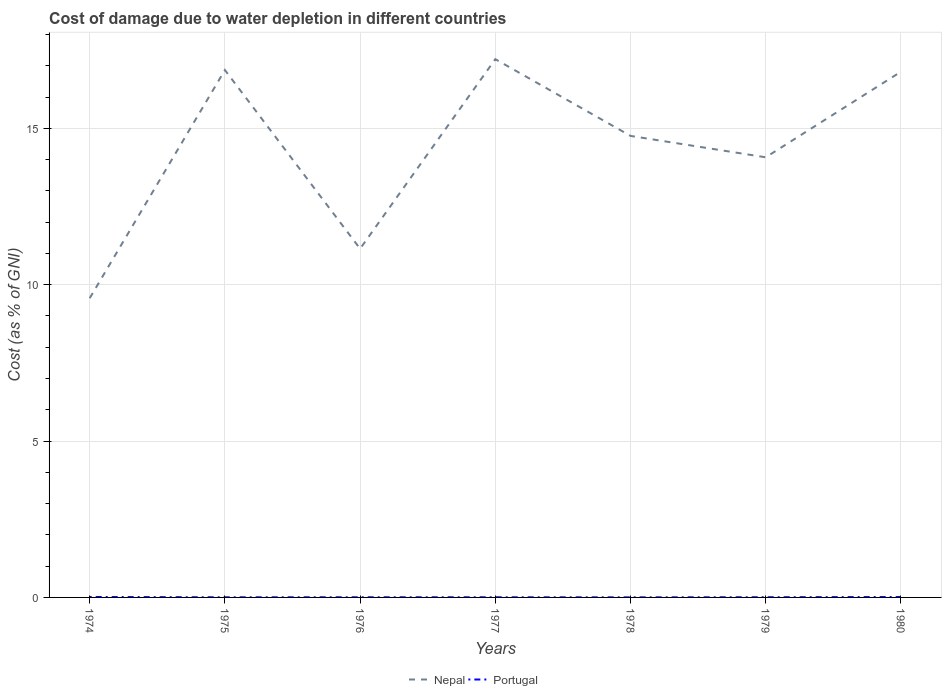How many different coloured lines are there?
Give a very brief answer. 2. Across all years, what is the maximum cost of damage caused due to water depletion in Nepal?
Make the answer very short. 9.57. In which year was the cost of damage caused due to water depletion in Nepal maximum?
Make the answer very short. 1974. What is the total cost of damage caused due to water depletion in Portugal in the graph?
Ensure brevity in your answer.  0.01. What is the difference between the highest and the second highest cost of damage caused due to water depletion in Nepal?
Your answer should be compact. 7.64. What is the title of the graph?
Provide a short and direct response. Cost of damage due to water depletion in different countries. Does "Sweden" appear as one of the legend labels in the graph?
Provide a short and direct response. No. What is the label or title of the Y-axis?
Give a very brief answer. Cost (as % of GNI). What is the Cost (as % of GNI) in Nepal in 1974?
Provide a short and direct response. 9.57. What is the Cost (as % of GNI) in Portugal in 1974?
Make the answer very short. 0.01. What is the Cost (as % of GNI) of Nepal in 1975?
Your response must be concise. 16.86. What is the Cost (as % of GNI) of Portugal in 1975?
Your answer should be very brief. 0. What is the Cost (as % of GNI) in Nepal in 1976?
Offer a terse response. 11.15. What is the Cost (as % of GNI) in Portugal in 1976?
Make the answer very short. 0.01. What is the Cost (as % of GNI) in Nepal in 1977?
Offer a terse response. 17.21. What is the Cost (as % of GNI) in Portugal in 1977?
Make the answer very short. 0. What is the Cost (as % of GNI) of Nepal in 1978?
Keep it short and to the point. 14.76. What is the Cost (as % of GNI) in Portugal in 1978?
Your answer should be compact. 0. What is the Cost (as % of GNI) of Nepal in 1979?
Provide a short and direct response. 14.07. What is the Cost (as % of GNI) of Portugal in 1979?
Ensure brevity in your answer.  0.01. What is the Cost (as % of GNI) in Nepal in 1980?
Offer a terse response. 16.81. What is the Cost (as % of GNI) in Portugal in 1980?
Your answer should be compact. 0.01. Across all years, what is the maximum Cost (as % of GNI) of Nepal?
Make the answer very short. 17.21. Across all years, what is the maximum Cost (as % of GNI) in Portugal?
Your answer should be very brief. 0.01. Across all years, what is the minimum Cost (as % of GNI) in Nepal?
Offer a very short reply. 9.57. Across all years, what is the minimum Cost (as % of GNI) of Portugal?
Provide a short and direct response. 0. What is the total Cost (as % of GNI) in Nepal in the graph?
Provide a short and direct response. 100.44. What is the total Cost (as % of GNI) of Portugal in the graph?
Give a very brief answer. 0.05. What is the difference between the Cost (as % of GNI) in Nepal in 1974 and that in 1975?
Offer a very short reply. -7.3. What is the difference between the Cost (as % of GNI) in Portugal in 1974 and that in 1975?
Ensure brevity in your answer.  0.01. What is the difference between the Cost (as % of GNI) in Nepal in 1974 and that in 1976?
Provide a succinct answer. -1.58. What is the difference between the Cost (as % of GNI) of Portugal in 1974 and that in 1976?
Keep it short and to the point. 0.01. What is the difference between the Cost (as % of GNI) in Nepal in 1974 and that in 1977?
Ensure brevity in your answer.  -7.64. What is the difference between the Cost (as % of GNI) of Portugal in 1974 and that in 1977?
Your answer should be very brief. 0.01. What is the difference between the Cost (as % of GNI) of Nepal in 1974 and that in 1978?
Give a very brief answer. -5.19. What is the difference between the Cost (as % of GNI) in Portugal in 1974 and that in 1978?
Ensure brevity in your answer.  0.01. What is the difference between the Cost (as % of GNI) of Nepal in 1974 and that in 1979?
Your answer should be very brief. -4.51. What is the difference between the Cost (as % of GNI) of Portugal in 1974 and that in 1979?
Offer a terse response. 0.01. What is the difference between the Cost (as % of GNI) of Nepal in 1974 and that in 1980?
Offer a terse response. -7.24. What is the difference between the Cost (as % of GNI) in Portugal in 1974 and that in 1980?
Make the answer very short. 0. What is the difference between the Cost (as % of GNI) of Nepal in 1975 and that in 1976?
Offer a terse response. 5.71. What is the difference between the Cost (as % of GNI) in Portugal in 1975 and that in 1976?
Your answer should be compact. -0. What is the difference between the Cost (as % of GNI) of Nepal in 1975 and that in 1977?
Offer a very short reply. -0.35. What is the difference between the Cost (as % of GNI) in Portugal in 1975 and that in 1977?
Your answer should be very brief. -0. What is the difference between the Cost (as % of GNI) in Nepal in 1975 and that in 1978?
Keep it short and to the point. 2.11. What is the difference between the Cost (as % of GNI) in Portugal in 1975 and that in 1978?
Ensure brevity in your answer.  0. What is the difference between the Cost (as % of GNI) in Nepal in 1975 and that in 1979?
Give a very brief answer. 2.79. What is the difference between the Cost (as % of GNI) of Portugal in 1975 and that in 1979?
Your answer should be very brief. -0. What is the difference between the Cost (as % of GNI) of Nepal in 1975 and that in 1980?
Your answer should be compact. 0.05. What is the difference between the Cost (as % of GNI) of Portugal in 1975 and that in 1980?
Provide a short and direct response. -0.01. What is the difference between the Cost (as % of GNI) of Nepal in 1976 and that in 1977?
Your answer should be compact. -6.06. What is the difference between the Cost (as % of GNI) of Portugal in 1976 and that in 1977?
Keep it short and to the point. 0. What is the difference between the Cost (as % of GNI) in Nepal in 1976 and that in 1978?
Offer a terse response. -3.61. What is the difference between the Cost (as % of GNI) in Portugal in 1976 and that in 1978?
Your response must be concise. 0. What is the difference between the Cost (as % of GNI) of Nepal in 1976 and that in 1979?
Your answer should be very brief. -2.92. What is the difference between the Cost (as % of GNI) of Portugal in 1976 and that in 1979?
Your response must be concise. -0. What is the difference between the Cost (as % of GNI) in Nepal in 1976 and that in 1980?
Your answer should be compact. -5.66. What is the difference between the Cost (as % of GNI) of Portugal in 1976 and that in 1980?
Your response must be concise. -0.01. What is the difference between the Cost (as % of GNI) in Nepal in 1977 and that in 1978?
Your answer should be compact. 2.45. What is the difference between the Cost (as % of GNI) in Portugal in 1977 and that in 1978?
Your answer should be very brief. 0. What is the difference between the Cost (as % of GNI) in Nepal in 1977 and that in 1979?
Keep it short and to the point. 3.14. What is the difference between the Cost (as % of GNI) in Portugal in 1977 and that in 1979?
Give a very brief answer. -0. What is the difference between the Cost (as % of GNI) in Nepal in 1977 and that in 1980?
Provide a succinct answer. 0.4. What is the difference between the Cost (as % of GNI) of Portugal in 1977 and that in 1980?
Your response must be concise. -0.01. What is the difference between the Cost (as % of GNI) in Nepal in 1978 and that in 1979?
Your answer should be very brief. 0.68. What is the difference between the Cost (as % of GNI) of Portugal in 1978 and that in 1979?
Provide a short and direct response. -0. What is the difference between the Cost (as % of GNI) in Nepal in 1978 and that in 1980?
Provide a short and direct response. -2.05. What is the difference between the Cost (as % of GNI) of Portugal in 1978 and that in 1980?
Provide a succinct answer. -0.01. What is the difference between the Cost (as % of GNI) of Nepal in 1979 and that in 1980?
Provide a short and direct response. -2.74. What is the difference between the Cost (as % of GNI) of Portugal in 1979 and that in 1980?
Your answer should be compact. -0.01. What is the difference between the Cost (as % of GNI) of Nepal in 1974 and the Cost (as % of GNI) of Portugal in 1975?
Provide a short and direct response. 9.56. What is the difference between the Cost (as % of GNI) in Nepal in 1974 and the Cost (as % of GNI) in Portugal in 1976?
Your answer should be very brief. 9.56. What is the difference between the Cost (as % of GNI) of Nepal in 1974 and the Cost (as % of GNI) of Portugal in 1977?
Provide a succinct answer. 9.56. What is the difference between the Cost (as % of GNI) of Nepal in 1974 and the Cost (as % of GNI) of Portugal in 1978?
Ensure brevity in your answer.  9.57. What is the difference between the Cost (as % of GNI) in Nepal in 1974 and the Cost (as % of GNI) in Portugal in 1979?
Give a very brief answer. 9.56. What is the difference between the Cost (as % of GNI) in Nepal in 1974 and the Cost (as % of GNI) in Portugal in 1980?
Make the answer very short. 9.56. What is the difference between the Cost (as % of GNI) of Nepal in 1975 and the Cost (as % of GNI) of Portugal in 1976?
Your answer should be compact. 16.86. What is the difference between the Cost (as % of GNI) of Nepal in 1975 and the Cost (as % of GNI) of Portugal in 1977?
Ensure brevity in your answer.  16.86. What is the difference between the Cost (as % of GNI) of Nepal in 1975 and the Cost (as % of GNI) of Portugal in 1978?
Your response must be concise. 16.86. What is the difference between the Cost (as % of GNI) in Nepal in 1975 and the Cost (as % of GNI) in Portugal in 1979?
Give a very brief answer. 16.86. What is the difference between the Cost (as % of GNI) of Nepal in 1975 and the Cost (as % of GNI) of Portugal in 1980?
Your answer should be very brief. 16.85. What is the difference between the Cost (as % of GNI) of Nepal in 1976 and the Cost (as % of GNI) of Portugal in 1977?
Provide a short and direct response. 11.15. What is the difference between the Cost (as % of GNI) in Nepal in 1976 and the Cost (as % of GNI) in Portugal in 1978?
Give a very brief answer. 11.15. What is the difference between the Cost (as % of GNI) in Nepal in 1976 and the Cost (as % of GNI) in Portugal in 1979?
Offer a very short reply. 11.14. What is the difference between the Cost (as % of GNI) of Nepal in 1976 and the Cost (as % of GNI) of Portugal in 1980?
Your answer should be compact. 11.14. What is the difference between the Cost (as % of GNI) in Nepal in 1977 and the Cost (as % of GNI) in Portugal in 1978?
Offer a very short reply. 17.21. What is the difference between the Cost (as % of GNI) of Nepal in 1977 and the Cost (as % of GNI) of Portugal in 1979?
Keep it short and to the point. 17.21. What is the difference between the Cost (as % of GNI) of Nepal in 1977 and the Cost (as % of GNI) of Portugal in 1980?
Keep it short and to the point. 17.2. What is the difference between the Cost (as % of GNI) in Nepal in 1978 and the Cost (as % of GNI) in Portugal in 1979?
Offer a terse response. 14.75. What is the difference between the Cost (as % of GNI) in Nepal in 1978 and the Cost (as % of GNI) in Portugal in 1980?
Offer a very short reply. 14.75. What is the difference between the Cost (as % of GNI) of Nepal in 1979 and the Cost (as % of GNI) of Portugal in 1980?
Your answer should be compact. 14.06. What is the average Cost (as % of GNI) in Nepal per year?
Offer a terse response. 14.35. What is the average Cost (as % of GNI) of Portugal per year?
Ensure brevity in your answer.  0.01. In the year 1974, what is the difference between the Cost (as % of GNI) in Nepal and Cost (as % of GNI) in Portugal?
Provide a short and direct response. 9.55. In the year 1975, what is the difference between the Cost (as % of GNI) in Nepal and Cost (as % of GNI) in Portugal?
Offer a very short reply. 16.86. In the year 1976, what is the difference between the Cost (as % of GNI) in Nepal and Cost (as % of GNI) in Portugal?
Your answer should be compact. 11.14. In the year 1977, what is the difference between the Cost (as % of GNI) of Nepal and Cost (as % of GNI) of Portugal?
Provide a succinct answer. 17.21. In the year 1978, what is the difference between the Cost (as % of GNI) of Nepal and Cost (as % of GNI) of Portugal?
Make the answer very short. 14.76. In the year 1979, what is the difference between the Cost (as % of GNI) of Nepal and Cost (as % of GNI) of Portugal?
Make the answer very short. 14.07. In the year 1980, what is the difference between the Cost (as % of GNI) of Nepal and Cost (as % of GNI) of Portugal?
Ensure brevity in your answer.  16.8. What is the ratio of the Cost (as % of GNI) of Nepal in 1974 to that in 1975?
Your answer should be compact. 0.57. What is the ratio of the Cost (as % of GNI) of Portugal in 1974 to that in 1975?
Give a very brief answer. 3.35. What is the ratio of the Cost (as % of GNI) in Nepal in 1974 to that in 1976?
Your answer should be compact. 0.86. What is the ratio of the Cost (as % of GNI) of Portugal in 1974 to that in 1976?
Make the answer very short. 2.76. What is the ratio of the Cost (as % of GNI) in Nepal in 1974 to that in 1977?
Offer a very short reply. 0.56. What is the ratio of the Cost (as % of GNI) of Portugal in 1974 to that in 1977?
Offer a terse response. 2.93. What is the ratio of the Cost (as % of GNI) in Nepal in 1974 to that in 1978?
Give a very brief answer. 0.65. What is the ratio of the Cost (as % of GNI) in Portugal in 1974 to that in 1978?
Provide a succinct answer. 6.19. What is the ratio of the Cost (as % of GNI) in Nepal in 1974 to that in 1979?
Provide a short and direct response. 0.68. What is the ratio of the Cost (as % of GNI) of Portugal in 1974 to that in 1979?
Keep it short and to the point. 2.16. What is the ratio of the Cost (as % of GNI) of Nepal in 1974 to that in 1980?
Provide a succinct answer. 0.57. What is the ratio of the Cost (as % of GNI) in Portugal in 1974 to that in 1980?
Your answer should be compact. 1.13. What is the ratio of the Cost (as % of GNI) in Nepal in 1975 to that in 1976?
Ensure brevity in your answer.  1.51. What is the ratio of the Cost (as % of GNI) in Portugal in 1975 to that in 1976?
Your answer should be compact. 0.82. What is the ratio of the Cost (as % of GNI) in Nepal in 1975 to that in 1977?
Your answer should be very brief. 0.98. What is the ratio of the Cost (as % of GNI) in Portugal in 1975 to that in 1977?
Make the answer very short. 0.88. What is the ratio of the Cost (as % of GNI) in Nepal in 1975 to that in 1978?
Your answer should be compact. 1.14. What is the ratio of the Cost (as % of GNI) in Portugal in 1975 to that in 1978?
Keep it short and to the point. 1.85. What is the ratio of the Cost (as % of GNI) of Nepal in 1975 to that in 1979?
Your answer should be compact. 1.2. What is the ratio of the Cost (as % of GNI) in Portugal in 1975 to that in 1979?
Offer a terse response. 0.65. What is the ratio of the Cost (as % of GNI) in Nepal in 1975 to that in 1980?
Provide a succinct answer. 1. What is the ratio of the Cost (as % of GNI) in Portugal in 1975 to that in 1980?
Give a very brief answer. 0.34. What is the ratio of the Cost (as % of GNI) in Nepal in 1976 to that in 1977?
Ensure brevity in your answer.  0.65. What is the ratio of the Cost (as % of GNI) in Portugal in 1976 to that in 1977?
Offer a terse response. 1.06. What is the ratio of the Cost (as % of GNI) in Nepal in 1976 to that in 1978?
Ensure brevity in your answer.  0.76. What is the ratio of the Cost (as % of GNI) of Portugal in 1976 to that in 1978?
Your answer should be compact. 2.24. What is the ratio of the Cost (as % of GNI) in Nepal in 1976 to that in 1979?
Your answer should be compact. 0.79. What is the ratio of the Cost (as % of GNI) in Portugal in 1976 to that in 1979?
Provide a succinct answer. 0.78. What is the ratio of the Cost (as % of GNI) of Nepal in 1976 to that in 1980?
Make the answer very short. 0.66. What is the ratio of the Cost (as % of GNI) of Portugal in 1976 to that in 1980?
Offer a very short reply. 0.41. What is the ratio of the Cost (as % of GNI) in Nepal in 1977 to that in 1978?
Offer a terse response. 1.17. What is the ratio of the Cost (as % of GNI) of Portugal in 1977 to that in 1978?
Give a very brief answer. 2.11. What is the ratio of the Cost (as % of GNI) of Nepal in 1977 to that in 1979?
Provide a succinct answer. 1.22. What is the ratio of the Cost (as % of GNI) in Portugal in 1977 to that in 1979?
Ensure brevity in your answer.  0.74. What is the ratio of the Cost (as % of GNI) in Nepal in 1977 to that in 1980?
Make the answer very short. 1.02. What is the ratio of the Cost (as % of GNI) in Portugal in 1977 to that in 1980?
Your answer should be compact. 0.39. What is the ratio of the Cost (as % of GNI) of Nepal in 1978 to that in 1979?
Your answer should be very brief. 1.05. What is the ratio of the Cost (as % of GNI) in Portugal in 1978 to that in 1979?
Give a very brief answer. 0.35. What is the ratio of the Cost (as % of GNI) of Nepal in 1978 to that in 1980?
Make the answer very short. 0.88. What is the ratio of the Cost (as % of GNI) in Portugal in 1978 to that in 1980?
Offer a very short reply. 0.18. What is the ratio of the Cost (as % of GNI) in Nepal in 1979 to that in 1980?
Your answer should be very brief. 0.84. What is the ratio of the Cost (as % of GNI) in Portugal in 1979 to that in 1980?
Your answer should be compact. 0.52. What is the difference between the highest and the second highest Cost (as % of GNI) in Nepal?
Offer a terse response. 0.35. What is the difference between the highest and the second highest Cost (as % of GNI) of Portugal?
Ensure brevity in your answer.  0. What is the difference between the highest and the lowest Cost (as % of GNI) of Nepal?
Provide a succinct answer. 7.64. What is the difference between the highest and the lowest Cost (as % of GNI) of Portugal?
Offer a very short reply. 0.01. 